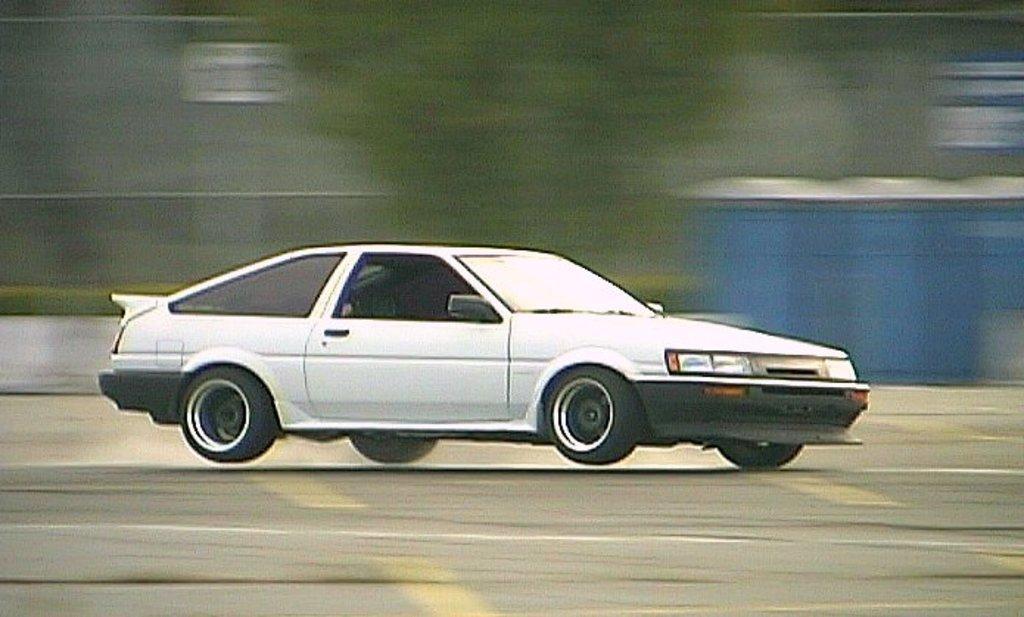How would you summarize this image in a sentence or two? In this image we can see a car on the road. 